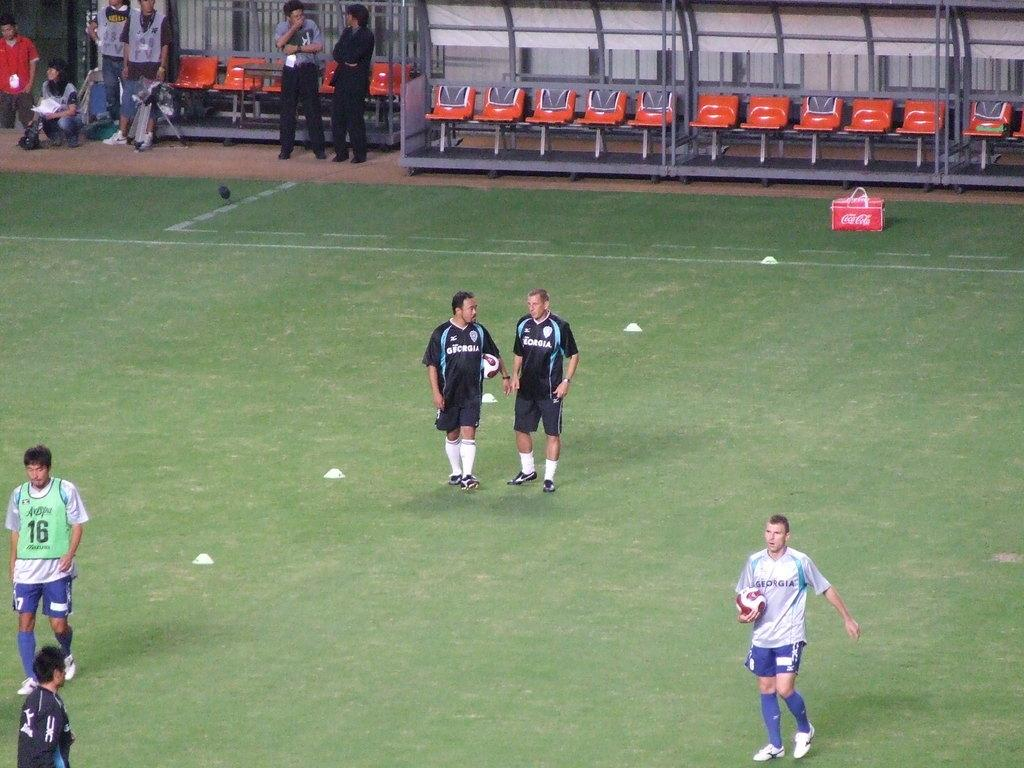<image>
Render a clear and concise summary of the photo. The guy to the left of the screen has a 16 vest on. 